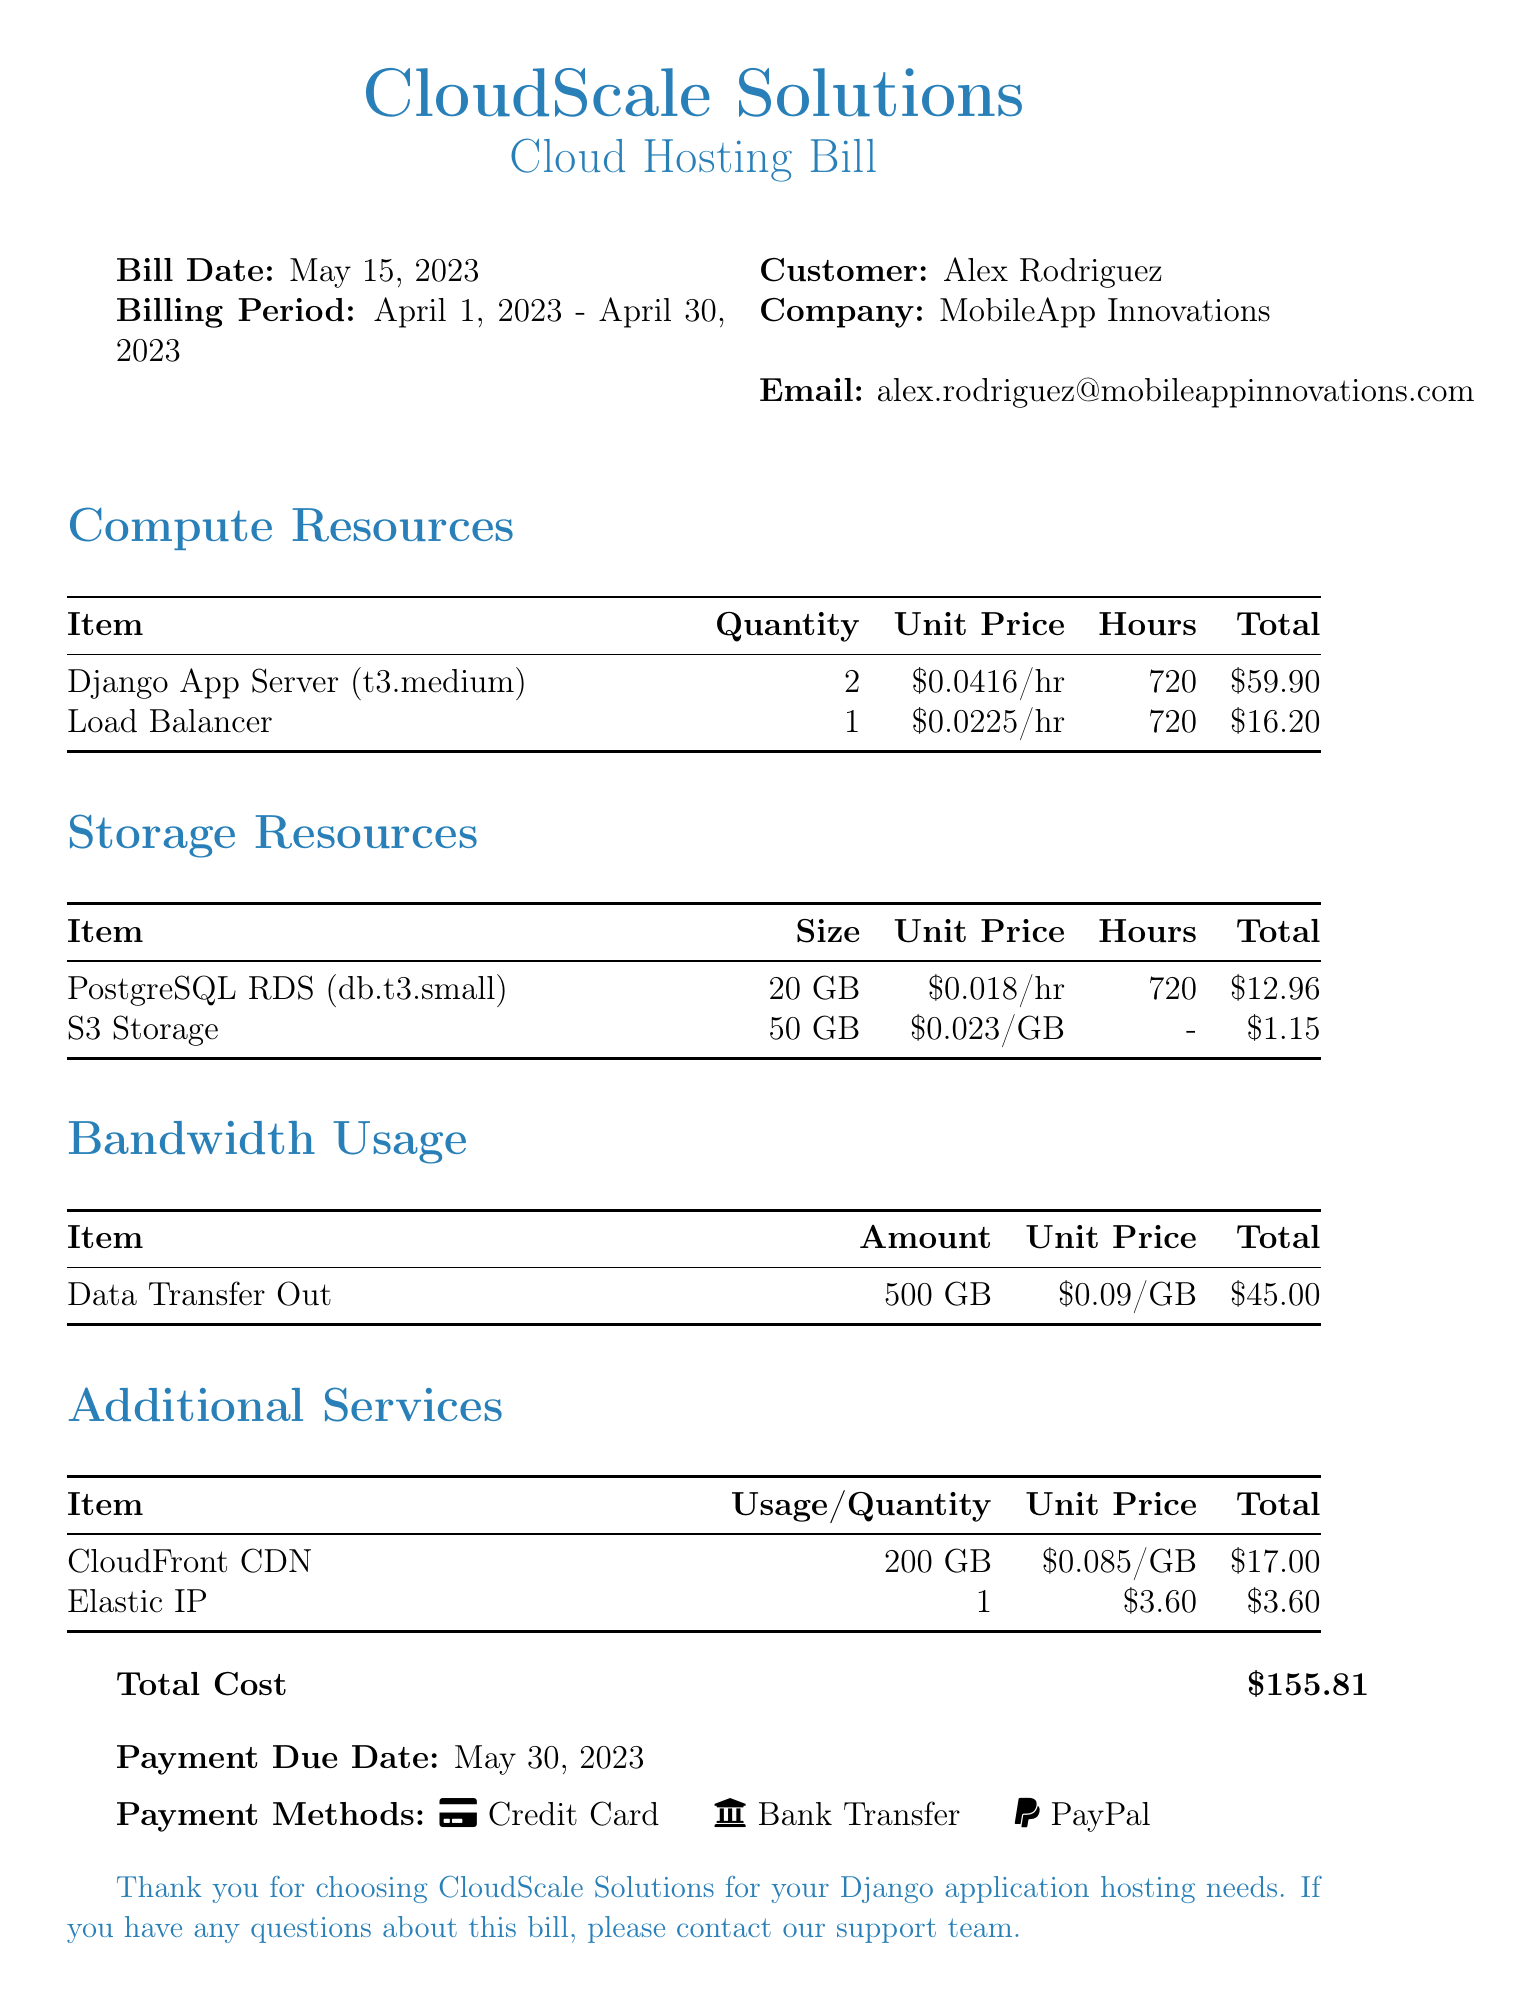What is the bill date? The bill date is stated clearly in the document for reference.
Answer: May 15, 2023 How many Django App Servers are listed? The document specifies the number of Django App Servers in the Compute Resources section.
Answer: 2 What is the total cost of storage resources? The total cost can be calculated based on the itemized storage resources listed in the document.
Answer: $14.11 What is the size of the PostgreSQL RDS? The size of the PostgreSQL RDS is indicated in the Storage Resources section.
Answer: 20 GB What payment methods are mentioned? The document lists the available payment methods at the end.
Answer: Credit Card, Bank Transfer, PayPal What is the total bandwidth usage cost? The total bandwidth usage cost is specified in the Bandwidth Usage section of the document.
Answer: $45.00 Which service costs $3.60? The document provides information on each service with their respective costs.
Answer: Elastic IP What is the payment due date? The payment due date is provided in the bill for information regarding payment deadlines.
Answer: May 30, 2023 